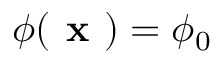Convert formula to latex. <formula><loc_0><loc_0><loc_500><loc_500>\phi ( x ) = \phi _ { 0 }</formula> 